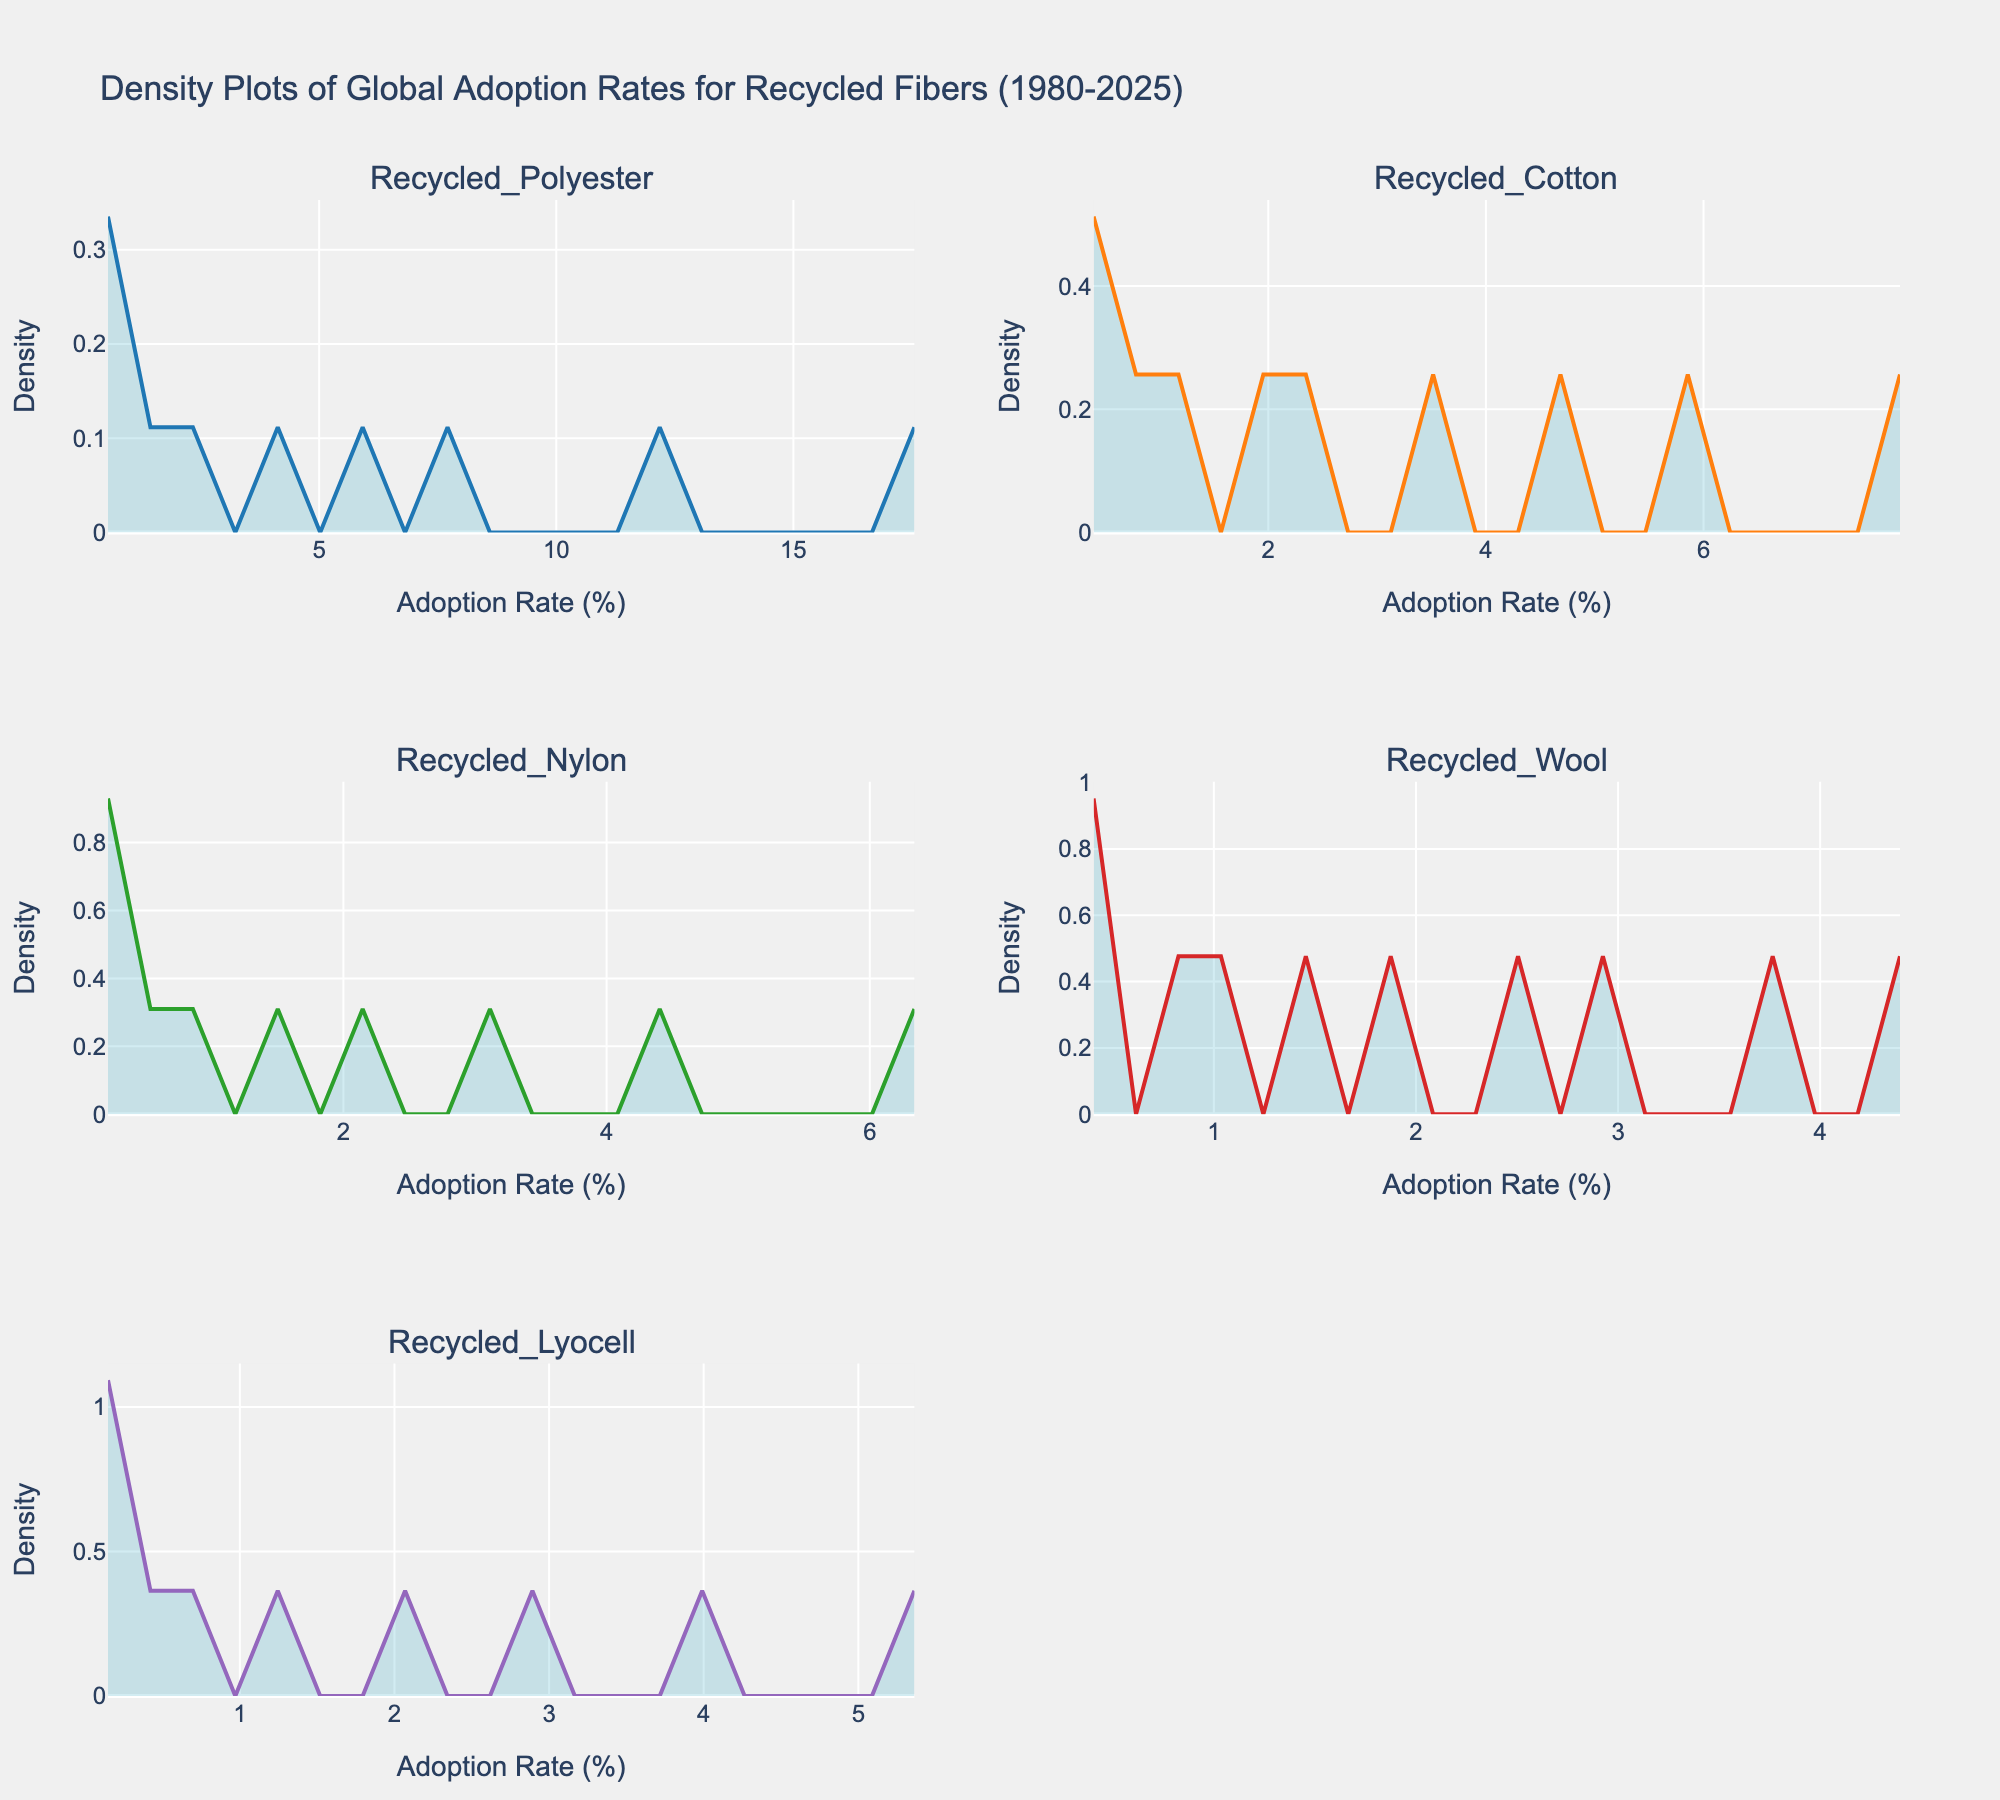What is the title of the figure? The title is displayed at the top of the figure, summarizing the subject of the density plots.
Answer: Density Plots of Global Adoption Rates for Recycled Fibers (1980-2025) Which recycled fiber has the highest peak density in its density plot? By closely examining all the subplots, you can see which line reaches the highest point.
Answer: Recycled Polyester What are the x-axis and y-axis labels for the subplots? The labels on the horizontal and vertical axes give information about the data being plotted: the x-axis is the adoption rate (%) and the y-axis is the density.
Answer: Adoption Rate (%) and Density How do the adoption rates of recycled polyester and recycled cotton compare visually? Compare the shapes and heights of the density plots for these two fibers. Recycled polyester shows a higher peak density and a broader spread along the x-axis compared to recycled cotton.
Answer: Recycled polyester has a higher peak and a broader spread compared to recycled cotton Which recycled fiber shows the most significant increase in adoption rates over time? Look at the increasing trends in the peaks of each density plot from left to right. Recycled polyester shows a consistently increasing density, indicating significant adoption growth.
Answer: Recycled Polyester What is the density value at the peak for recycled wool? Locate the highest point (peak) in the recycled wool subplot and read the corresponding y-axis value.
Answer: About 0.5 Comparing recycled nylon and recycled lyocell, which fiber shows a more concentrated distribution? Analyze how narrow and tall the densities are in the subplots. Recycled nylon displays a more peaked and narrow distribution, while recycled lyocell is more spread out.
Answer: Recycled Nylon Which recycled fiber appears to have a bimodal distribution? Examine the subplots for any fiber that has two distinct peaks. None of the fibers exhibit a clear bimodal distribution; they are all unimodal with a single peak.
Answer: None Based on the density plots, which recycled fiber had the earliest significant adoption rate spike? Identify the plots and see which one has a significant increase in density values starting from an earlier year. Recycled wool shows early adoption with a significant spike as early as 1980.
Answer: Recycled Wool 